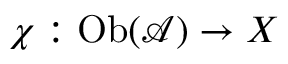<formula> <loc_0><loc_0><loc_500><loc_500>\chi \colon O b ( { \mathcal { A } } ) \to X</formula> 